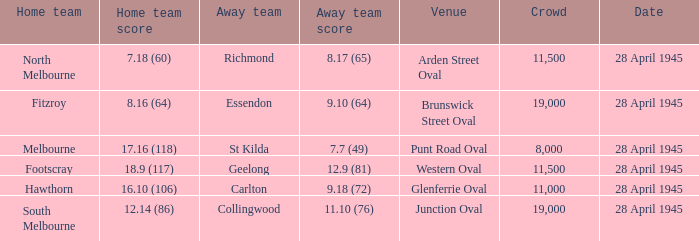Which home team has an Away team of essendon? 8.16 (64). 